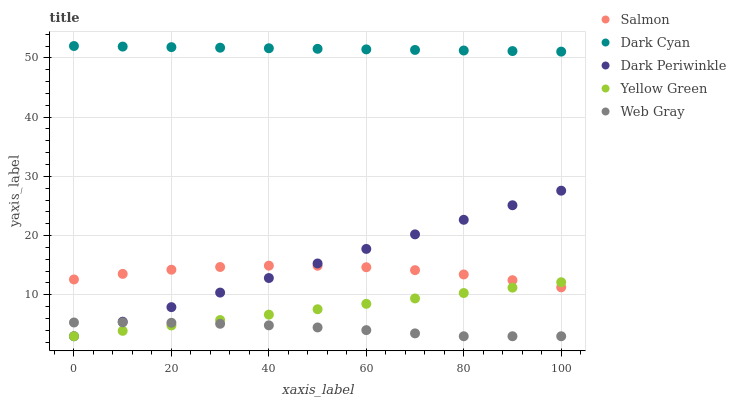Does Web Gray have the minimum area under the curve?
Answer yes or no. Yes. Does Dark Cyan have the maximum area under the curve?
Answer yes or no. Yes. Does Salmon have the minimum area under the curve?
Answer yes or no. No. Does Salmon have the maximum area under the curve?
Answer yes or no. No. Is Dark Cyan the smoothest?
Answer yes or no. Yes. Is Salmon the roughest?
Answer yes or no. Yes. Is Web Gray the smoothest?
Answer yes or no. No. Is Web Gray the roughest?
Answer yes or no. No. Does Web Gray have the lowest value?
Answer yes or no. Yes. Does Salmon have the lowest value?
Answer yes or no. No. Does Dark Cyan have the highest value?
Answer yes or no. Yes. Does Salmon have the highest value?
Answer yes or no. No. Is Web Gray less than Dark Cyan?
Answer yes or no. Yes. Is Dark Cyan greater than Salmon?
Answer yes or no. Yes. Does Salmon intersect Yellow Green?
Answer yes or no. Yes. Is Salmon less than Yellow Green?
Answer yes or no. No. Is Salmon greater than Yellow Green?
Answer yes or no. No. Does Web Gray intersect Dark Cyan?
Answer yes or no. No. 